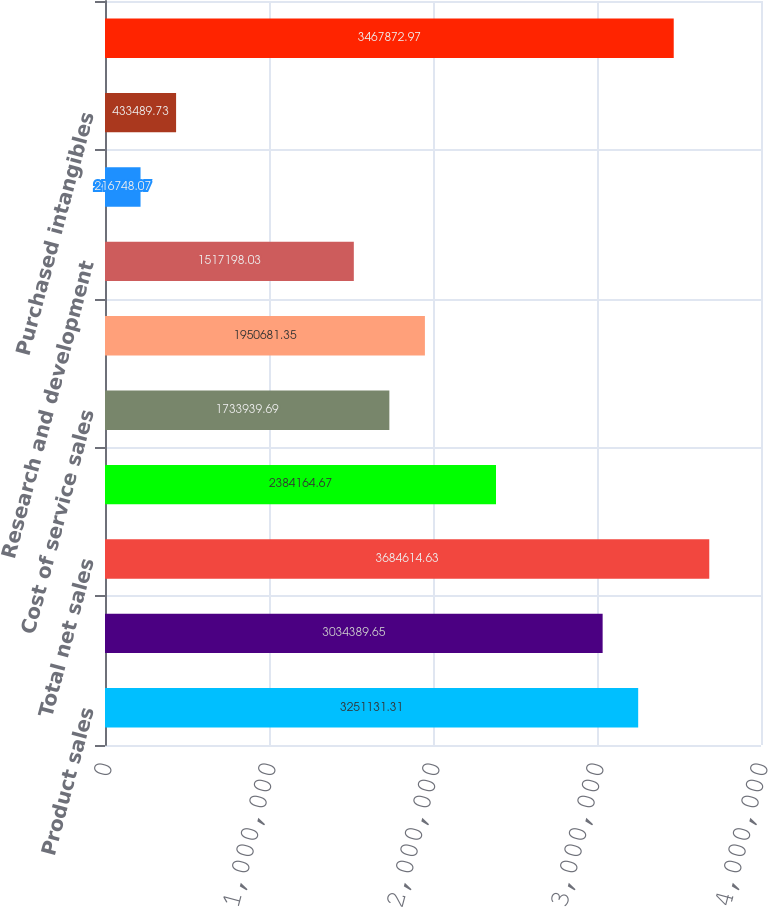<chart> <loc_0><loc_0><loc_500><loc_500><bar_chart><fcel>Product sales<fcel>Service sales<fcel>Total net sales<fcel>Cost of product sales<fcel>Cost of service sales<fcel>Selling and administrative<fcel>Research and development<fcel>Litigation provisions (Note<fcel>Purchased intangibles<fcel>Total costs and operating<nl><fcel>3.25113e+06<fcel>3.03439e+06<fcel>3.68461e+06<fcel>2.38416e+06<fcel>1.73394e+06<fcel>1.95068e+06<fcel>1.5172e+06<fcel>216748<fcel>433490<fcel>3.46787e+06<nl></chart> 